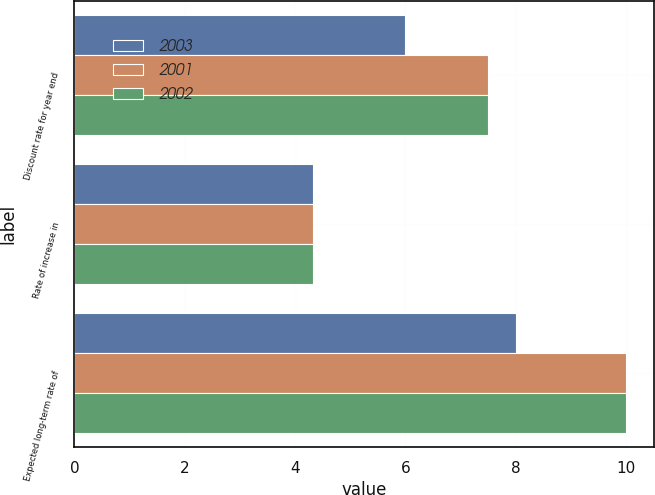Convert chart. <chart><loc_0><loc_0><loc_500><loc_500><stacked_bar_chart><ecel><fcel>Discount rate for year end<fcel>Rate of increase in<fcel>Expected long-term rate of<nl><fcel>2003<fcel>6<fcel>4.33<fcel>8<nl><fcel>2001<fcel>7.5<fcel>4.33<fcel>10<nl><fcel>2002<fcel>7.5<fcel>4.33<fcel>10<nl></chart> 